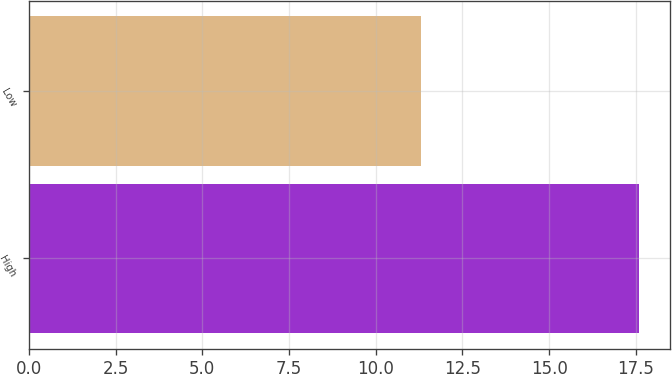<chart> <loc_0><loc_0><loc_500><loc_500><bar_chart><fcel>High<fcel>Low<nl><fcel>17.6<fcel>11.31<nl></chart> 